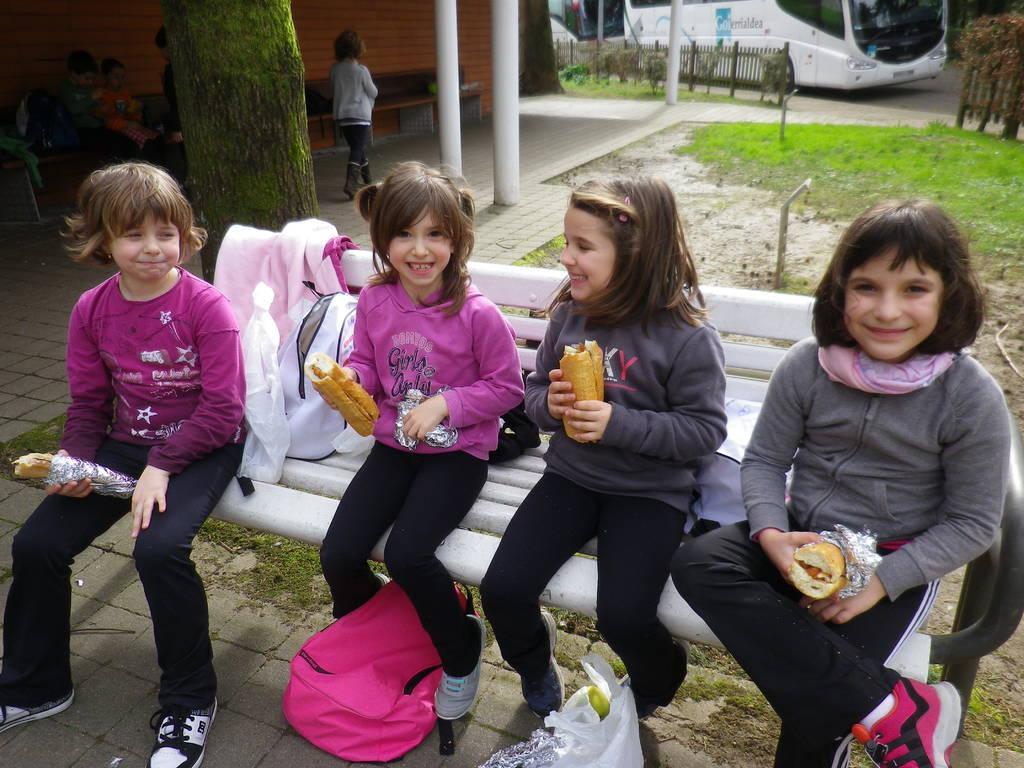Can you describe this image briefly? In this picture there are four children were sitting on the bench and everyone is holding burger. At the bottom we can see the bag and plastic covers. In the top left there is a girl who is standing near to the pillars, beside her we can see the group of persons were sitting on the bench near to the brick wall. In the background there is a bus which is parked near to the wooden fencing and plants. On the right we can see the grass and road. 